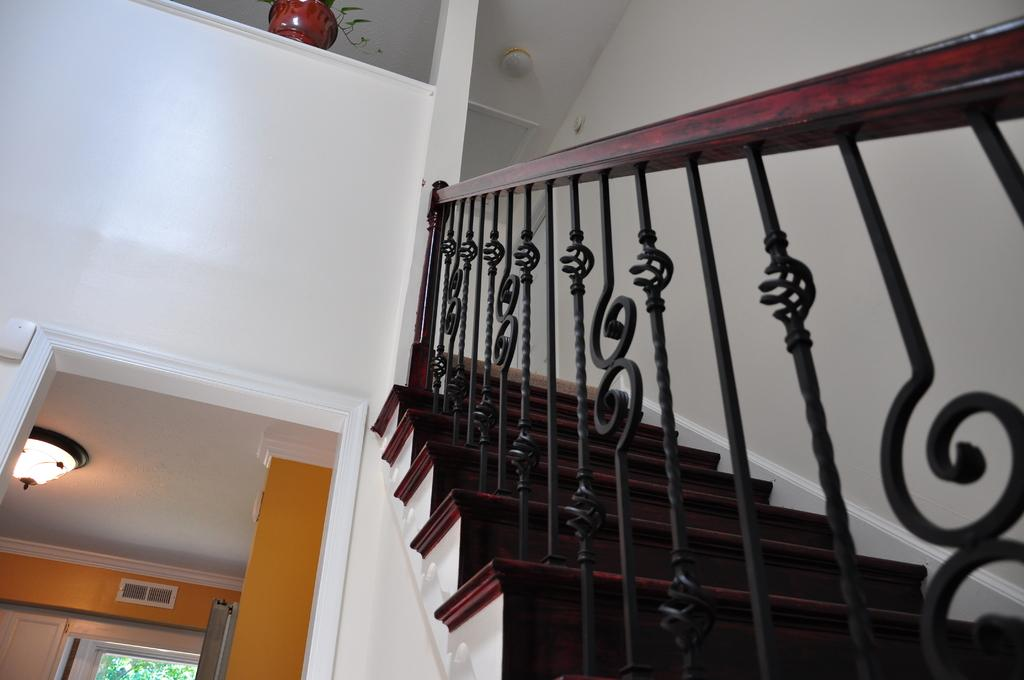What type of structure can be seen in the image? There is a railing and stairs in the image. What is located near the stairs? There is a flower pot in the image. What type of illumination is present in the image? There is a light in the image. What type of background can be seen in the image? There is a wall and trees in the image. What type of bun is being used to make a decision in the image? There is no bun or decision-making process depicted in the image. How many eggs are visible in the image? There are no eggs present in the image. 